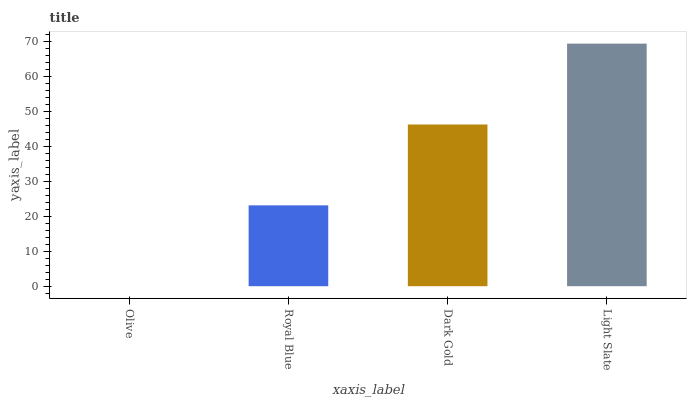Is Olive the minimum?
Answer yes or no. Yes. Is Light Slate the maximum?
Answer yes or no. Yes. Is Royal Blue the minimum?
Answer yes or no. No. Is Royal Blue the maximum?
Answer yes or no. No. Is Royal Blue greater than Olive?
Answer yes or no. Yes. Is Olive less than Royal Blue?
Answer yes or no. Yes. Is Olive greater than Royal Blue?
Answer yes or no. No. Is Royal Blue less than Olive?
Answer yes or no. No. Is Dark Gold the high median?
Answer yes or no. Yes. Is Royal Blue the low median?
Answer yes or no. Yes. Is Olive the high median?
Answer yes or no. No. Is Dark Gold the low median?
Answer yes or no. No. 